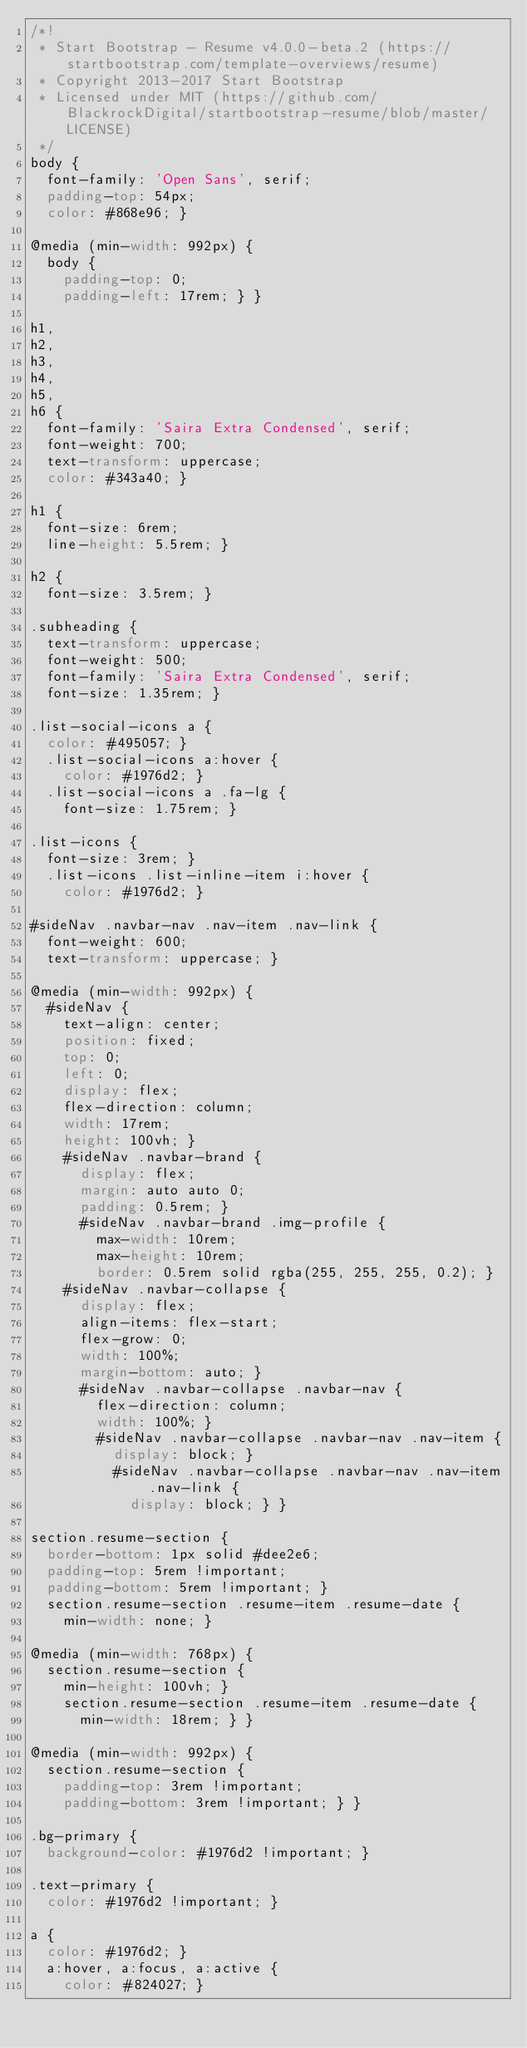Convert code to text. <code><loc_0><loc_0><loc_500><loc_500><_CSS_>/*!
 * Start Bootstrap - Resume v4.0.0-beta.2 (https://startbootstrap.com/template-overviews/resume)
 * Copyright 2013-2017 Start Bootstrap
 * Licensed under MIT (https://github.com/BlackrockDigital/startbootstrap-resume/blob/master/LICENSE)
 */
body {
  font-family: 'Open Sans', serif;
  padding-top: 54px;
  color: #868e96; }

@media (min-width: 992px) {
  body {
    padding-top: 0;
    padding-left: 17rem; } }

h1,
h2,
h3,
h4,
h5,
h6 {
  font-family: 'Saira Extra Condensed', serif;
  font-weight: 700;
  text-transform: uppercase;
  color: #343a40; }

h1 {
  font-size: 6rem;
  line-height: 5.5rem; }

h2 {
  font-size: 3.5rem; }

.subheading {
  text-transform: uppercase;
  font-weight: 500;
  font-family: 'Saira Extra Condensed', serif;
  font-size: 1.35rem; }

.list-social-icons a {
  color: #495057; }
  .list-social-icons a:hover {
    color: #1976d2; }
  .list-social-icons a .fa-lg {
    font-size: 1.75rem; }

.list-icons {
  font-size: 3rem; }
  .list-icons .list-inline-item i:hover {
    color: #1976d2; }

#sideNav .navbar-nav .nav-item .nav-link {
  font-weight: 600;
  text-transform: uppercase; }

@media (min-width: 992px) {
  #sideNav {
    text-align: center;
    position: fixed;
    top: 0;
    left: 0;
    display: flex;
    flex-direction: column;
    width: 17rem;
    height: 100vh; }
    #sideNav .navbar-brand {
      display: flex;
      margin: auto auto 0;
      padding: 0.5rem; }
      #sideNav .navbar-brand .img-profile {
        max-width: 10rem;
        max-height: 10rem;
        border: 0.5rem solid rgba(255, 255, 255, 0.2); }
    #sideNav .navbar-collapse {
      display: flex;
      align-items: flex-start;
      flex-grow: 0;
      width: 100%;
      margin-bottom: auto; }
      #sideNav .navbar-collapse .navbar-nav {
        flex-direction: column;
        width: 100%; }
        #sideNav .navbar-collapse .navbar-nav .nav-item {
          display: block; }
          #sideNav .navbar-collapse .navbar-nav .nav-item .nav-link {
            display: block; } }

section.resume-section {
  border-bottom: 1px solid #dee2e6;
  padding-top: 5rem !important;
  padding-bottom: 5rem !important; }
  section.resume-section .resume-item .resume-date {
    min-width: none; }

@media (min-width: 768px) {
  section.resume-section {
    min-height: 100vh; }
    section.resume-section .resume-item .resume-date {
      min-width: 18rem; } }

@media (min-width: 992px) {
  section.resume-section {
    padding-top: 3rem !important;
    padding-bottom: 3rem !important; } }

.bg-primary {
  background-color: #1976d2 !important; }

.text-primary {
  color: #1976d2 !important; }

a {
  color: #1976d2; }
  a:hover, a:focus, a:active {
    color: #824027; }
</code> 